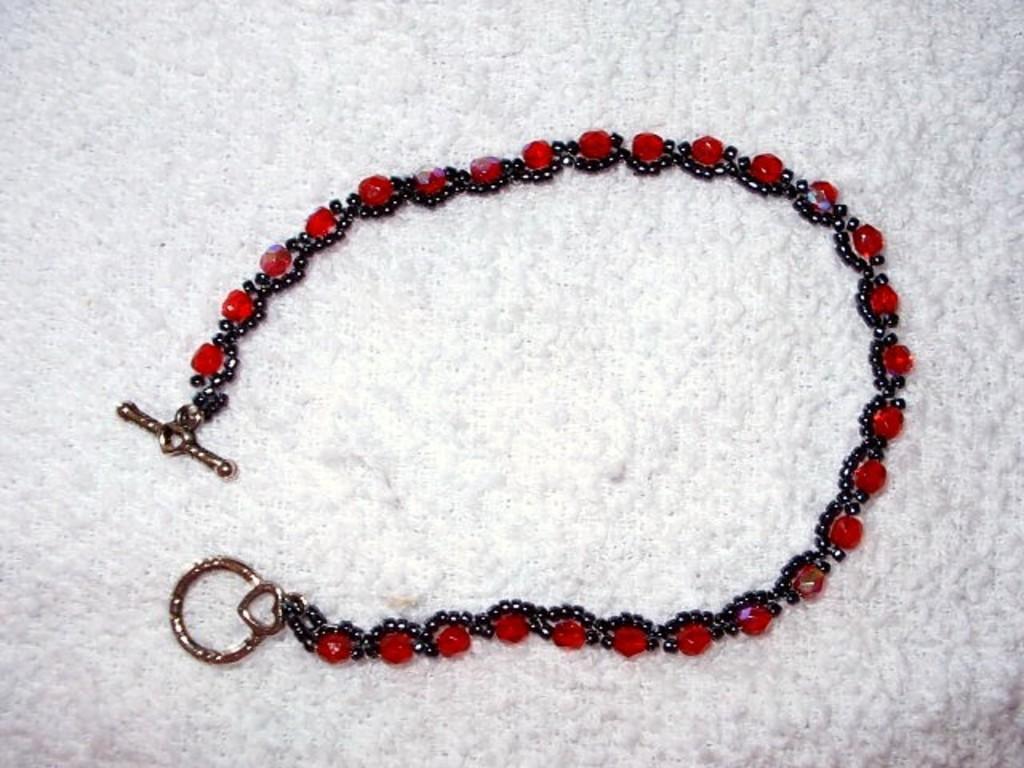Can you describe this image briefly? Here I can see an ornament which is made up of red and black color gems. It is placed on a white surface. 